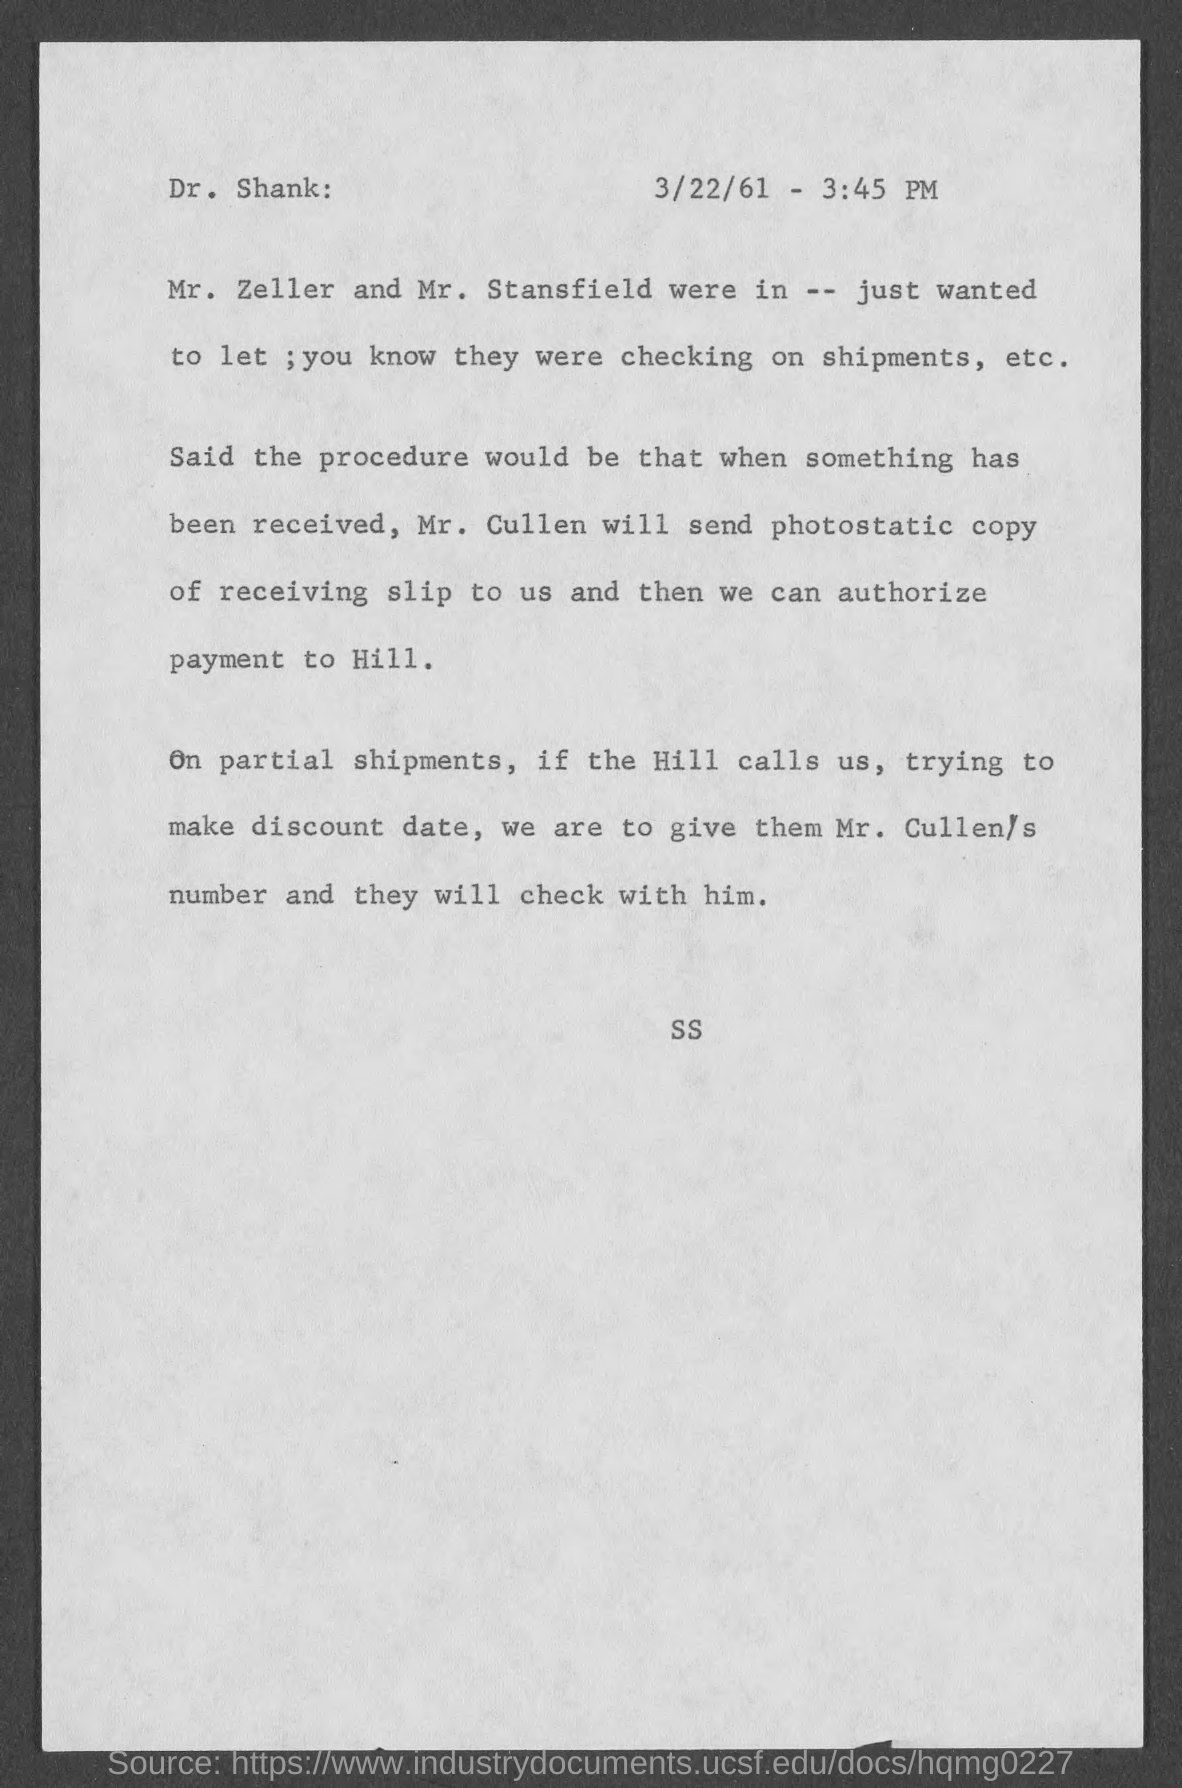When is the document dated?
Provide a short and direct response. 3/22/61. What is the time given?
Offer a very short reply. 3:45 PM. Who will send photostatic copy of receiving slip?
Give a very brief answer. Mr. cullen. 